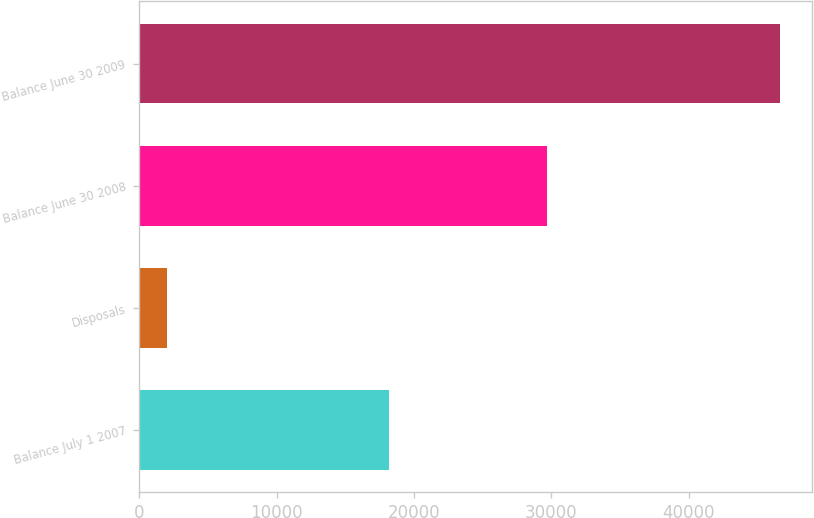<chart> <loc_0><loc_0><loc_500><loc_500><bar_chart><fcel>Balance July 1 2007<fcel>Disposals<fcel>Balance June 30 2008<fcel>Balance June 30 2009<nl><fcel>18177<fcel>1993<fcel>29689<fcel>46592<nl></chart> 